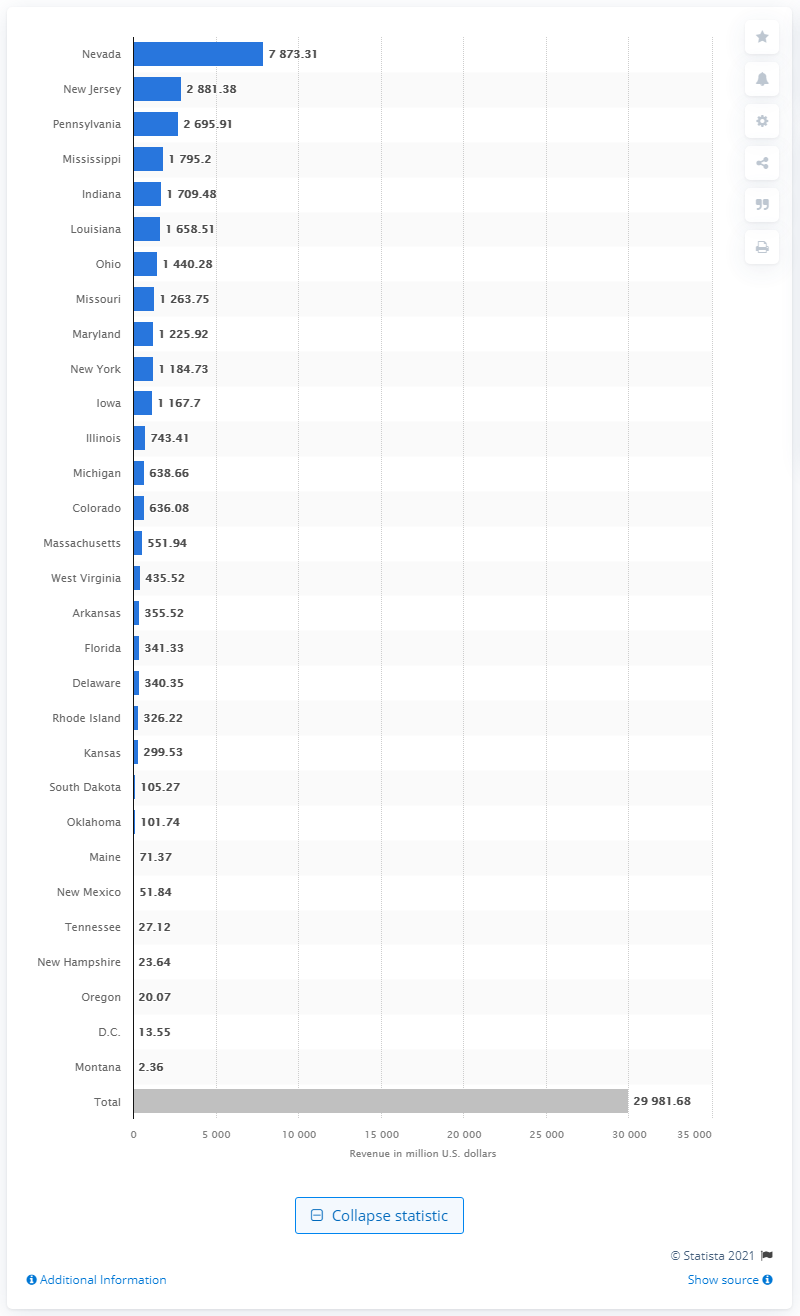Specify some key components in this picture. In 2020, Nevada's gross gaming revenue was $78,73.31. The total gross gaming revenue of U.S. casinos in 2020 was approximately $299,816.80. 